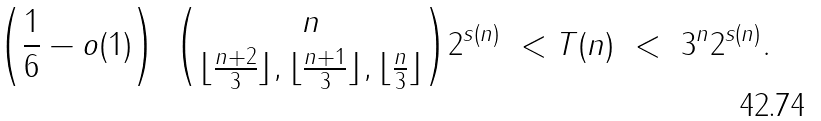<formula> <loc_0><loc_0><loc_500><loc_500>\left ( \frac { 1 } { 6 } - o ( 1 ) \right ) \ \binom { n } { \lfloor \frac { n + 2 } { 3 } \rfloor , \lfloor \frac { n + 1 } { 3 } \rfloor , \lfloor \frac { n } { 3 } \rfloor } 2 ^ { s ( n ) } \ < T ( n ) \ < \ 3 ^ { n } 2 ^ { s ( n ) } .</formula> 